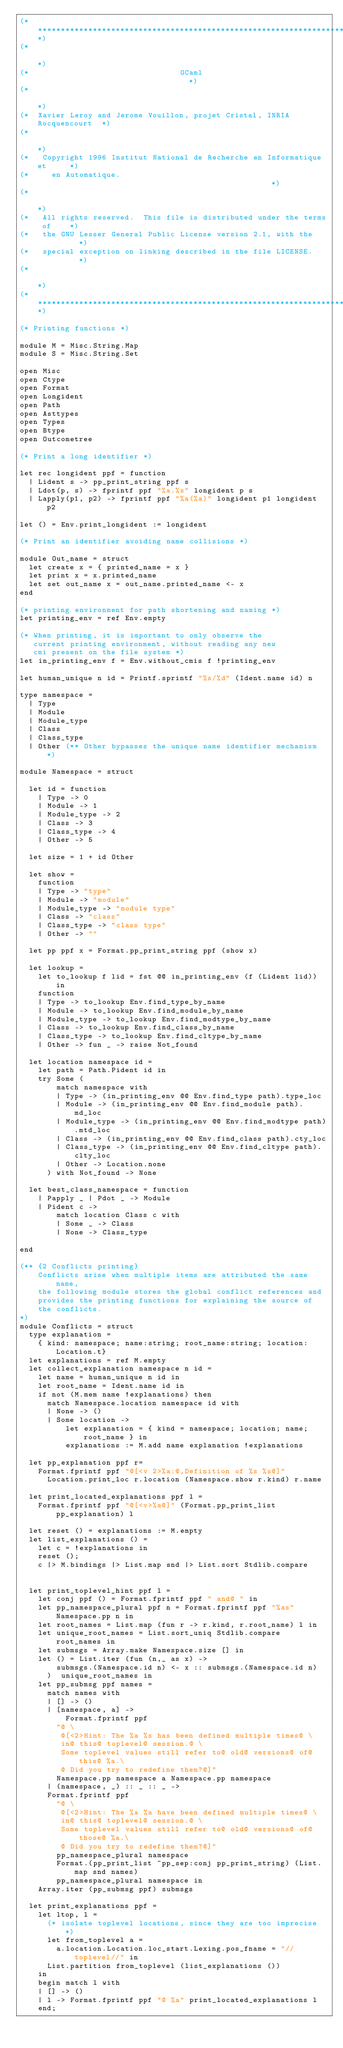Convert code to text. <code><loc_0><loc_0><loc_500><loc_500><_OCaml_>(**************************************************************************)
(*                                                                        *)
(*                                 OCaml                                  *)
(*                                                                        *)
(*  Xavier Leroy and Jerome Vouillon, projet Cristal, INRIA Rocquencourt  *)
(*                                                                        *)
(*   Copyright 1996 Institut National de Recherche en Informatique et     *)
(*     en Automatique.                                                    *)
(*                                                                        *)
(*   All rights reserved.  This file is distributed under the terms of    *)
(*   the GNU Lesser General Public License version 2.1, with the          *)
(*   special exception on linking described in the file LICENSE.          *)
(*                                                                        *)
(**************************************************************************)

(* Printing functions *)

module M = Misc.String.Map
module S = Misc.String.Set

open Misc
open Ctype
open Format
open Longident
open Path
open Asttypes
open Types
open Btype
open Outcometree

(* Print a long identifier *)

let rec longident ppf = function
  | Lident s -> pp_print_string ppf s
  | Ldot(p, s) -> fprintf ppf "%a.%s" longident p s
  | Lapply(p1, p2) -> fprintf ppf "%a(%a)" longident p1 longident p2

let () = Env.print_longident := longident

(* Print an identifier avoiding name collisions *)

module Out_name = struct
  let create x = { printed_name = x }
  let print x = x.printed_name
  let set out_name x = out_name.printed_name <- x
end

(* printing environment for path shortening and naming *)
let printing_env = ref Env.empty

(* When printing, it is important to only observe the
   current printing environment, without reading any new
   cmi present on the file system *)
let in_printing_env f = Env.without_cmis f !printing_env

let human_unique n id = Printf.sprintf "%s/%d" (Ident.name id) n

type namespace =
  | Type
  | Module
  | Module_type
  | Class
  | Class_type
  | Other (** Other bypasses the unique name identifier mechanism *)

module Namespace = struct

  let id = function
    | Type -> 0
    | Module -> 1
    | Module_type -> 2
    | Class -> 3
    | Class_type -> 4
    | Other -> 5

  let size = 1 + id Other

  let show =
    function
    | Type -> "type"
    | Module -> "module"
    | Module_type -> "module type"
    | Class -> "class"
    | Class_type -> "class type"
    | Other -> ""

  let pp ppf x = Format.pp_print_string ppf (show x)

  let lookup =
    let to_lookup f lid = fst @@ in_printing_env (f (Lident lid)) in
    function
    | Type -> to_lookup Env.find_type_by_name
    | Module -> to_lookup Env.find_module_by_name
    | Module_type -> to_lookup Env.find_modtype_by_name
    | Class -> to_lookup Env.find_class_by_name
    | Class_type -> to_lookup Env.find_cltype_by_name
    | Other -> fun _ -> raise Not_found

  let location namespace id =
    let path = Path.Pident id in
    try Some (
        match namespace with
        | Type -> (in_printing_env @@ Env.find_type path).type_loc
        | Module -> (in_printing_env @@ Env.find_module path).md_loc
        | Module_type -> (in_printing_env @@ Env.find_modtype path).mtd_loc
        | Class -> (in_printing_env @@ Env.find_class path).cty_loc
        | Class_type -> (in_printing_env @@ Env.find_cltype path).clty_loc
        | Other -> Location.none
      ) with Not_found -> None

  let best_class_namespace = function
    | Papply _ | Pdot _ -> Module
    | Pident c ->
        match location Class c with
        | Some _ -> Class
        | None -> Class_type

end

(** {2 Conflicts printing}
    Conflicts arise when multiple items are attributed the same name,
    the following module stores the global conflict references and
    provides the printing functions for explaining the source of
    the conflicts.
*)
module Conflicts = struct
  type explanation =
    { kind: namespace; name:string; root_name:string; location:Location.t}
  let explanations = ref M.empty
  let collect_explanation namespace n id =
    let name = human_unique n id in
    let root_name = Ident.name id in
    if not (M.mem name !explanations) then
      match Namespace.location namespace id with
      | None -> ()
      | Some location ->
          let explanation = { kind = namespace; location; name; root_name } in
          explanations := M.add name explanation !explanations

  let pp_explanation ppf r=
    Format.fprintf ppf "@[<v 2>%a:@,Definition of %s %s@]"
      Location.print_loc r.location (Namespace.show r.kind) r.name

  let print_located_explanations ppf l =
    Format.fprintf ppf "@[<v>%a@]" (Format.pp_print_list pp_explanation) l

  let reset () = explanations := M.empty
  let list_explanations () =
    let c = !explanations in
    reset ();
    c |> M.bindings |> List.map snd |> List.sort Stdlib.compare


  let print_toplevel_hint ppf l =
    let conj ppf () = Format.fprintf ppf " and@ " in
    let pp_namespace_plural ppf n = Format.fprintf ppf "%as" Namespace.pp n in
    let root_names = List.map (fun r -> r.kind, r.root_name) l in
    let unique_root_names = List.sort_uniq Stdlib.compare root_names in
    let submsgs = Array.make Namespace.size [] in
    let () = List.iter (fun (n,_ as x) ->
        submsgs.(Namespace.id n) <- x :: submsgs.(Namespace.id n)
      )  unique_root_names in
    let pp_submsg ppf names =
      match names with
      | [] -> ()
      | [namespace, a] ->
          Format.fprintf ppf
        "@ \
         @[<2>Hint: The %a %s has been defined multiple times@ \
         in@ this@ toplevel@ session.@ \
         Some toplevel values still refer to@ old@ versions@ of@ this@ %a.\
         @ Did you try to redefine them?@]"
        Namespace.pp namespace a Namespace.pp namespace
      | (namespace, _) :: _ :: _ ->
      Format.fprintf ppf
        "@ \
         @[<2>Hint: The %a %a have been defined multiple times@ \
         in@ this@ toplevel@ session.@ \
         Some toplevel values still refer to@ old@ versions@ of@ those@ %a.\
         @ Did you try to redefine them?@]"
        pp_namespace_plural namespace
        Format.(pp_print_list ~pp_sep:conj pp_print_string) (List.map snd names)
        pp_namespace_plural namespace in
    Array.iter (pp_submsg ppf) submsgs

  let print_explanations ppf =
    let ltop, l =
      (* isolate toplevel locations, since they are too imprecise *)
      let from_toplevel a =
        a.location.Location.loc_start.Lexing.pos_fname = "//toplevel//" in
      List.partition from_toplevel (list_explanations ())
    in
    begin match l with
    | [] -> ()
    | l -> Format.fprintf ppf "@ %a" print_located_explanations l
    end;</code> 